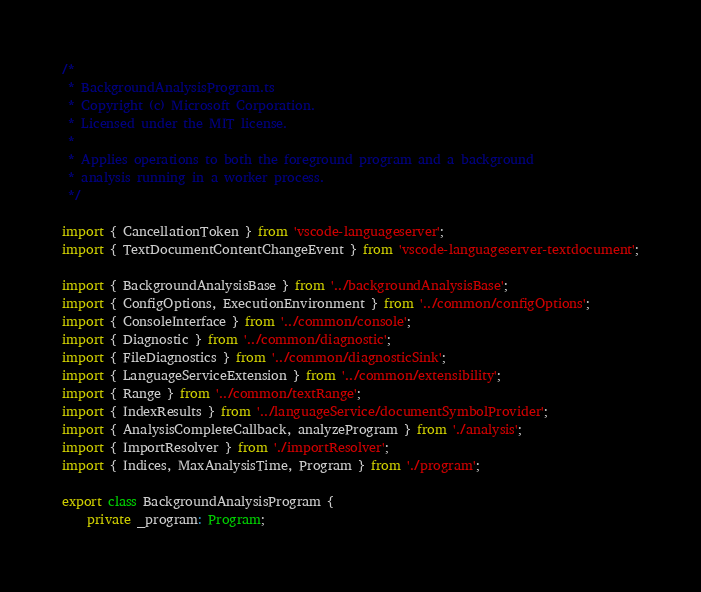<code> <loc_0><loc_0><loc_500><loc_500><_TypeScript_>/*
 * BackgroundAnalysisProgram.ts
 * Copyright (c) Microsoft Corporation.
 * Licensed under the MIT license.
 *
 * Applies operations to both the foreground program and a background
 * analysis running in a worker process.
 */

import { CancellationToken } from 'vscode-languageserver';
import { TextDocumentContentChangeEvent } from 'vscode-languageserver-textdocument';

import { BackgroundAnalysisBase } from '../backgroundAnalysisBase';
import { ConfigOptions, ExecutionEnvironment } from '../common/configOptions';
import { ConsoleInterface } from '../common/console';
import { Diagnostic } from '../common/diagnostic';
import { FileDiagnostics } from '../common/diagnosticSink';
import { LanguageServiceExtension } from '../common/extensibility';
import { Range } from '../common/textRange';
import { IndexResults } from '../languageService/documentSymbolProvider';
import { AnalysisCompleteCallback, analyzeProgram } from './analysis';
import { ImportResolver } from './importResolver';
import { Indices, MaxAnalysisTime, Program } from './program';

export class BackgroundAnalysisProgram {
    private _program: Program;</code> 